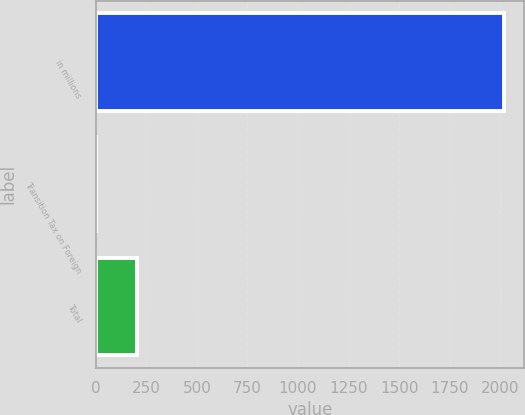Convert chart to OTSL. <chart><loc_0><loc_0><loc_500><loc_500><bar_chart><fcel>in millions<fcel>Transition Tax on Foreign<fcel>Total<nl><fcel>2018<fcel>0.1<fcel>201.89<nl></chart> 